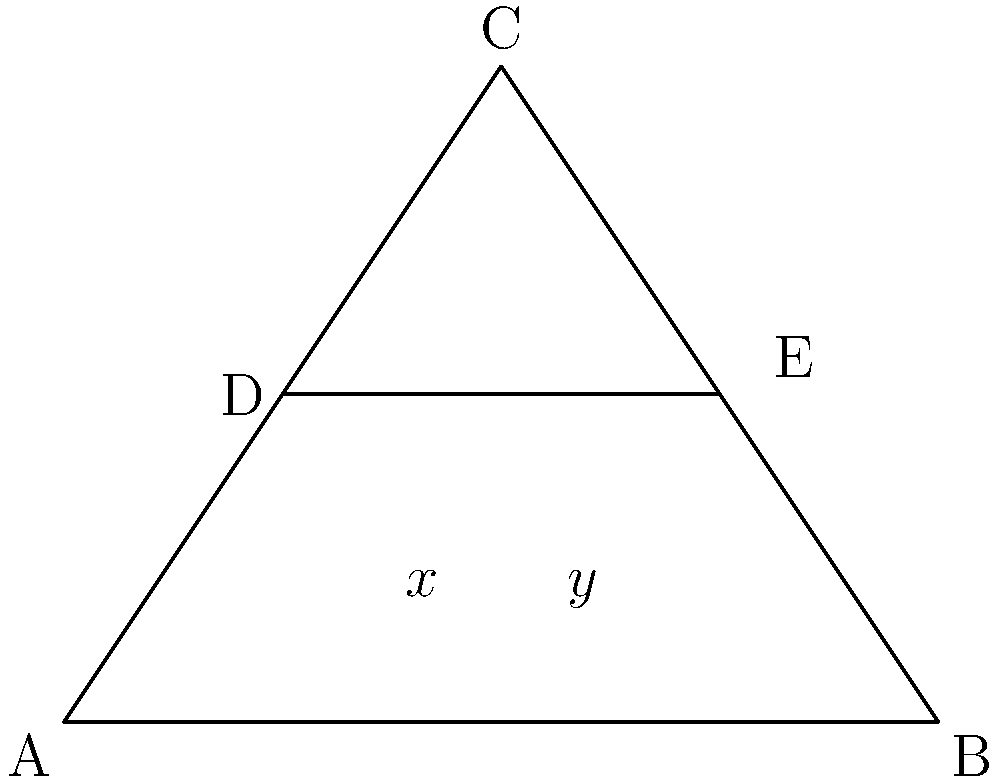In your latest abstract painting, you've incorporated wood grain patterns using intersecting straight lines. The triangle ABC represents the canvas, while line DE mimics a prominent wood grain. If angle CAB measures 36° and angle ABC measures 72°, what is the value of $x + y$? Let's approach this step-by-step:

1) First, we need to find the measure of angle BCA:
   $$180° - (36° + 72°) = 72°$$
   This is because the sum of angles in a triangle is always 180°.

2) Now, let's focus on the line DE. It creates two pairs of alternate angles with the sides of the triangle:
   - $x$ is alternate to angle CAB (36°)
   - $y$ is alternate to angle BCA (72°)

3) Due to the alternate angle theorem:
   $$x = 36°$$
   $$y = 72°$$

4) The question asks for $x + y$:
   $$x + y = 36° + 72° = 108°$$

Therefore, the sum of $x$ and $y$ is 108°.
Answer: 108° 